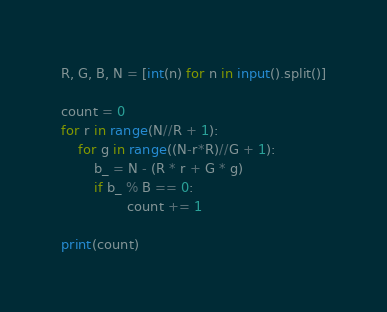<code> <loc_0><loc_0><loc_500><loc_500><_Python_>R, G, B, N = [int(n) for n in input().split()]

count = 0
for r in range(N//R + 1):
    for g in range((N-r*R)//G + 1):
        b_ = N - (R * r + G * g) 
        if b_ % B == 0:
                count += 1

print(count)
</code> 